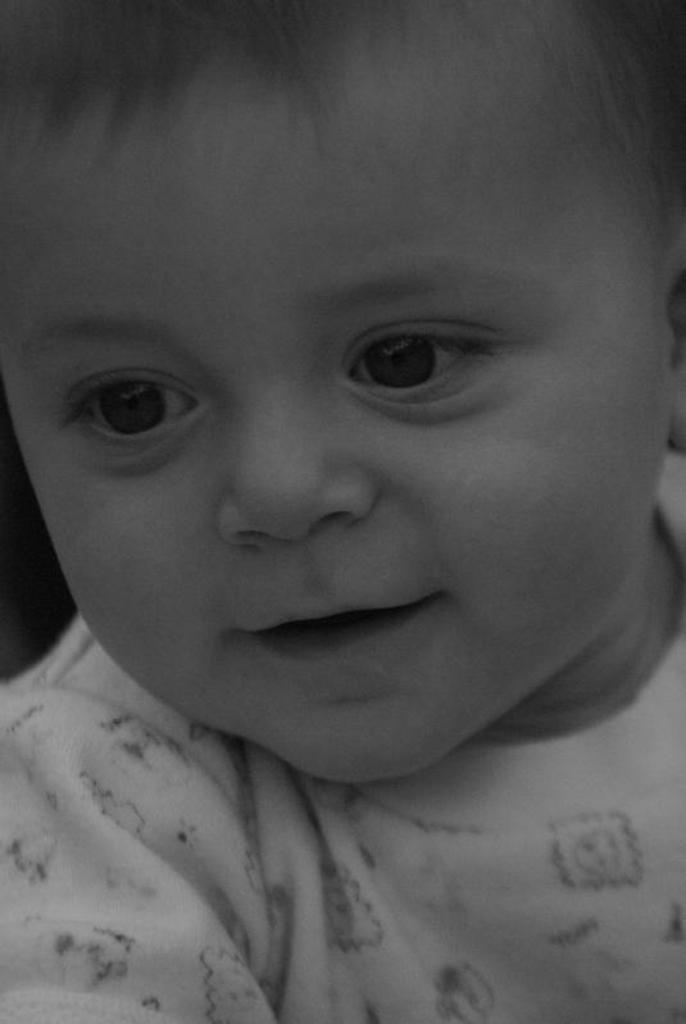What is the main subject of the image? There is a small baby in the image. Where is the baby located in the image? The baby is in the center of the image. What type of scissors is the baby using in the image? There are no scissors present in the image; the baby is the main subject. 